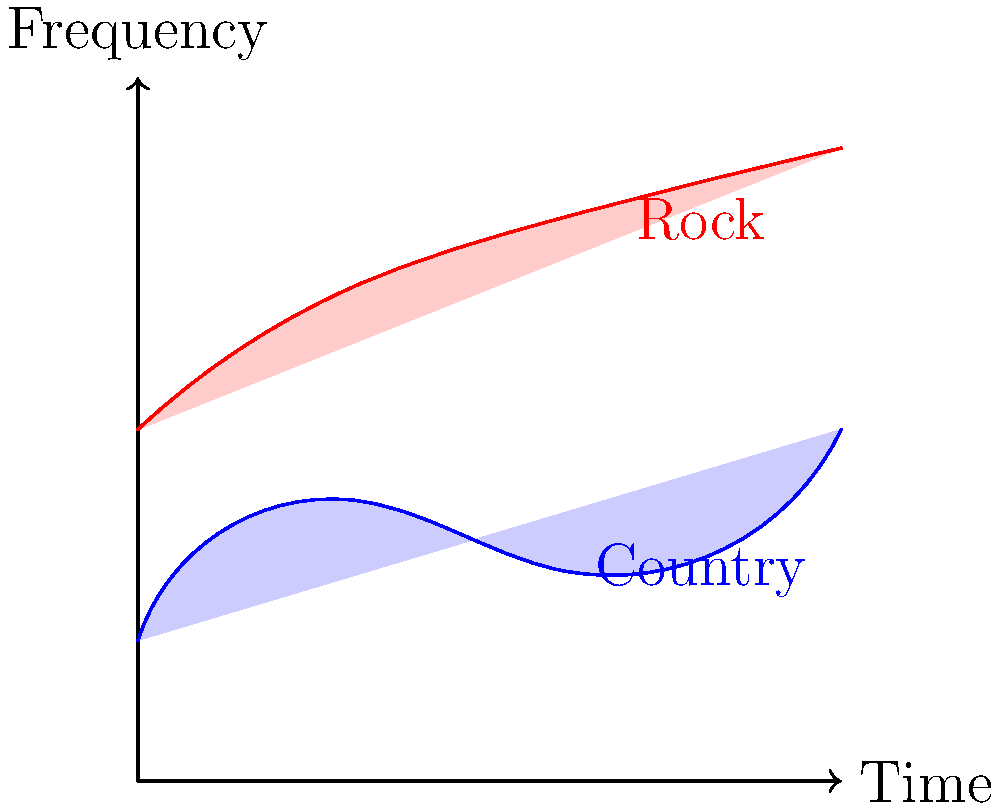As a songwriter who has worked with The Band Perry, you're familiar with both country and rock music. Based on the spectrograms shown in the image, which characteristic best distinguishes the rock genre from the country genre? To answer this question, let's analyze the spectrograms step-by-step:

1. The x-axis represents time, and the y-axis represents frequency.

2. The blue spectrogram represents country music, while the red spectrogram represents rock music.

3. Observing the country (blue) spectrogram:
   - It has lower overall frequency content
   - The frequency range is narrower
   - The intensity (opacity) is lower

4. Observing the rock (red) spectrogram:
   - It has higher overall frequency content
   - The frequency range is wider
   - The intensity (opacity) is higher

5. The key difference between the two spectrograms is the frequency content:
   - Rock music consistently shows higher frequencies throughout the time range
   - Country music shows lower frequencies and a narrower frequency range

6. This aligns with typical characteristics of these genres:
   - Rock music often features electric guitars, heavy drum beats, and intense vocals, resulting in higher frequency content
   - Country music typically has softer instrumentation, with acoustic guitars and smoother vocals, resulting in lower frequency content

Therefore, the most distinguishing characteristic of rock music compared to country music, based on these spectrograms, is its higher frequency content.
Answer: Higher frequency content 